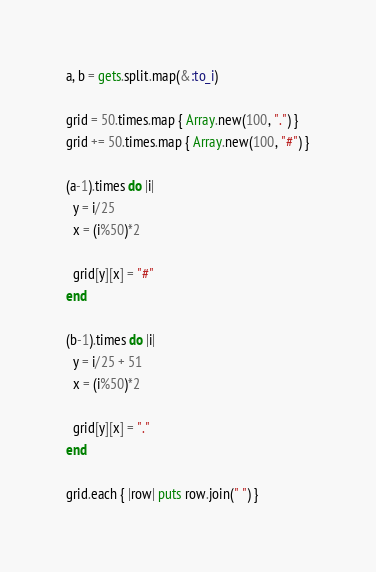<code> <loc_0><loc_0><loc_500><loc_500><_Ruby_>a, b = gets.split.map(&:to_i)

grid = 50.times.map { Array.new(100, ".") }
grid += 50.times.map { Array.new(100, "#") }

(a-1).times do |i|
  y = i/25
  x = (i%50)*2

  grid[y][x] = "#"
end

(b-1).times do |i|
  y = i/25 + 51
  x = (i%50)*2

  grid[y][x] = "."
end

grid.each { |row| puts row.join(" ") }
</code> 